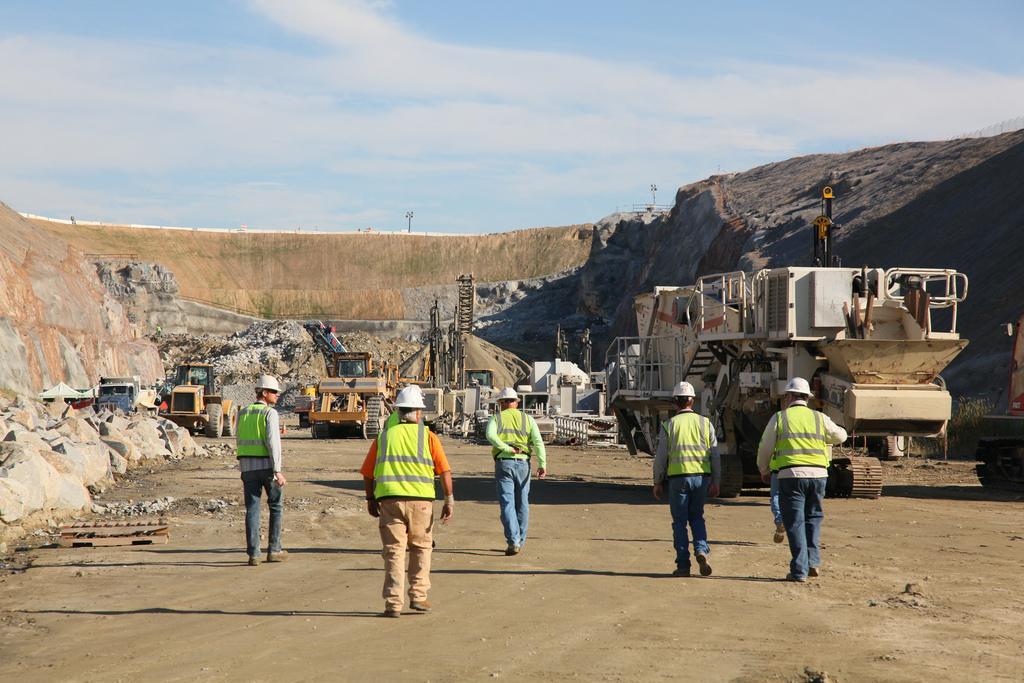How would you summarize this image in a sentence or two? In this image we can see people and there are vehicles. There are rocks. In the background there is sky and we can see poles. 